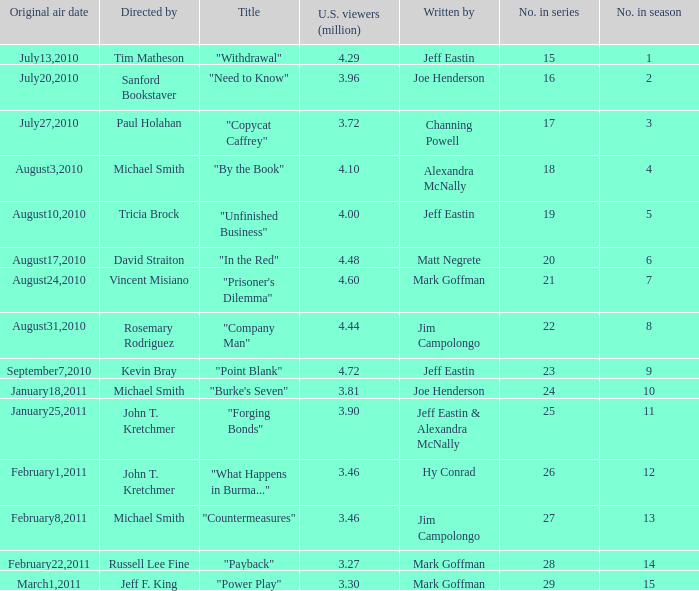How many millions of people in the US watched when Kevin Bray was director? 4.72. 